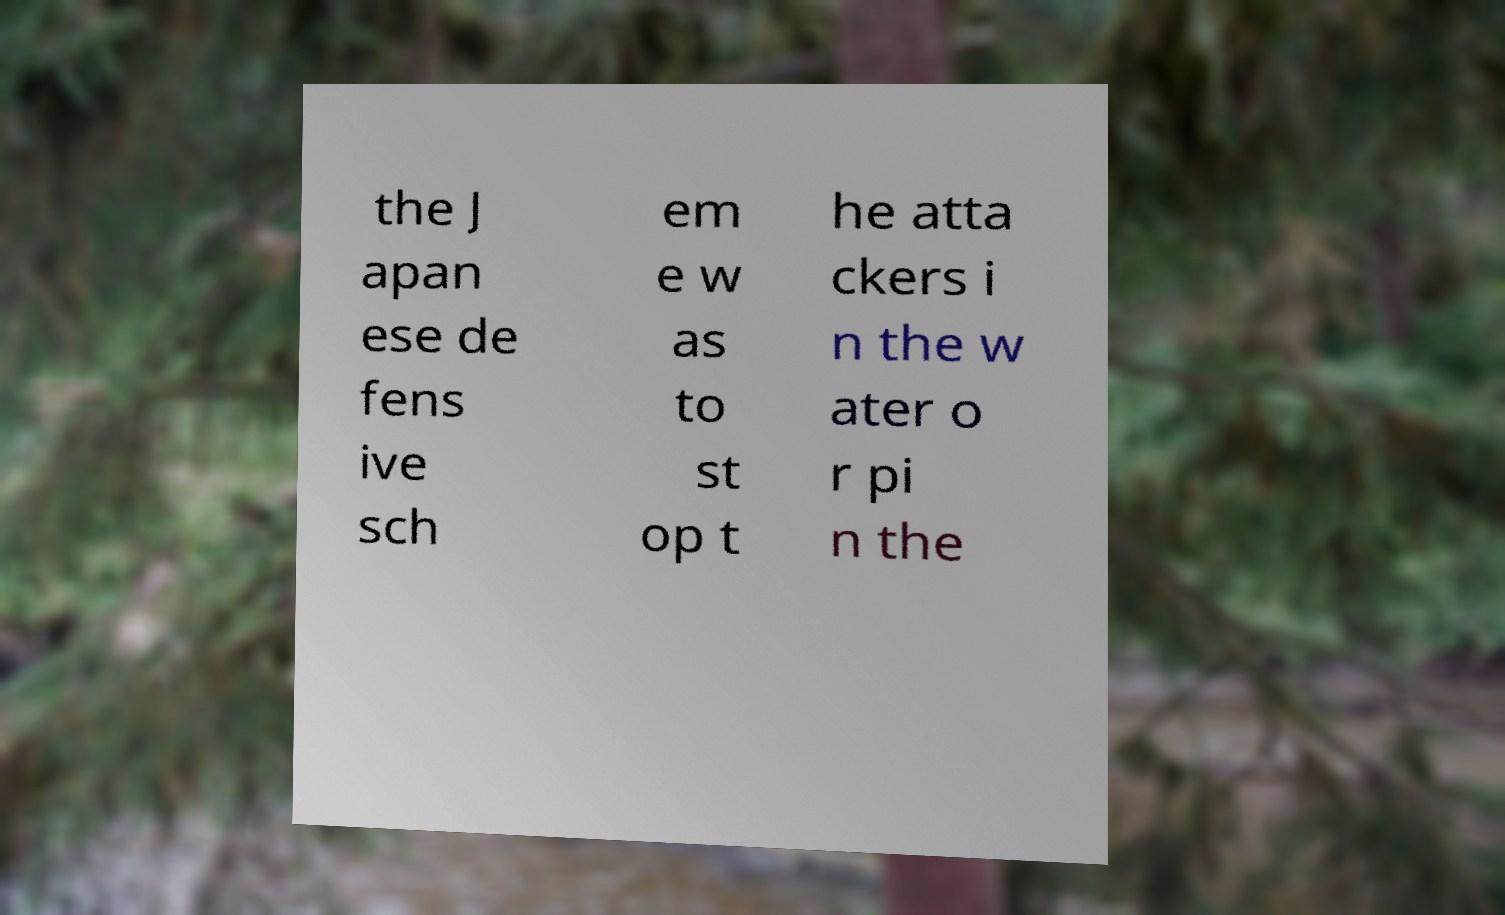What messages or text are displayed in this image? I need them in a readable, typed format. the J apan ese de fens ive sch em e w as to st op t he atta ckers i n the w ater o r pi n the 